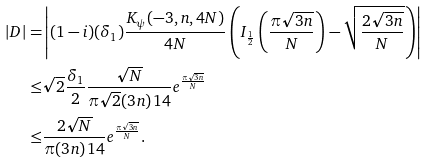Convert formula to latex. <formula><loc_0><loc_0><loc_500><loc_500>| D | = & \left | ( 1 - i ) ( \delta _ { 1 } ) \frac { K _ { \psi } ( - 3 , n , 4 N ) } { 4 N } \left ( I _ { \frac { 1 } { 2 } } \left ( \frac { \pi \sqrt { 3 n } } { N } \right ) - \sqrt { \frac { 2 \sqrt { 3 n } } { N } } \right ) \right | \\ \leq & \sqrt { 2 } \frac { \delta _ { 1 } } { 2 } \frac { \sqrt { N } } { \pi \sqrt { 2 } ( 3 n ) ^ { } { 1 } 4 } e ^ { \frac { \pi \sqrt { 3 n } } { N } } \\ \leq & \frac { 2 \sqrt { N } } { \pi ( 3 n ) ^ { } { 1 } 4 } e ^ { \frac { \pi \sqrt { 3 n } } { N } } .</formula> 